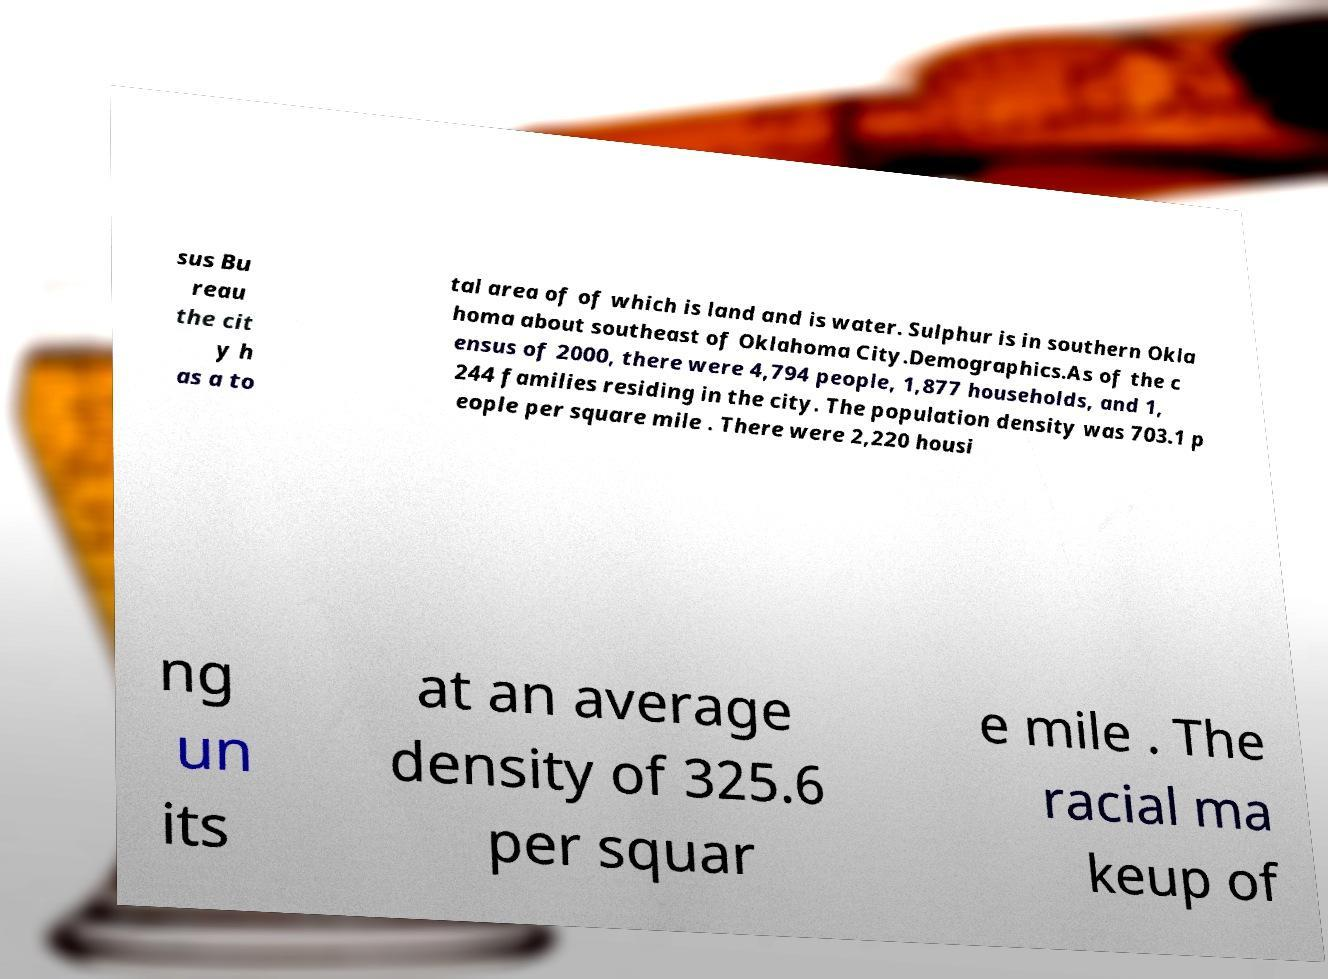I need the written content from this picture converted into text. Can you do that? sus Bu reau the cit y h as a to tal area of of which is land and is water. Sulphur is in southern Okla homa about southeast of Oklahoma City.Demographics.As of the c ensus of 2000, there were 4,794 people, 1,877 households, and 1, 244 families residing in the city. The population density was 703.1 p eople per square mile . There were 2,220 housi ng un its at an average density of 325.6 per squar e mile . The racial ma keup of 